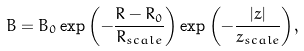<formula> <loc_0><loc_0><loc_500><loc_500>B = B _ { 0 } \exp { \left ( - \frac { R - R _ { 0 } } { R _ { s c a l e } } \right ) } \exp { \left ( - \frac { | z | } { z _ { s c a l e } } \right ) } ,</formula> 